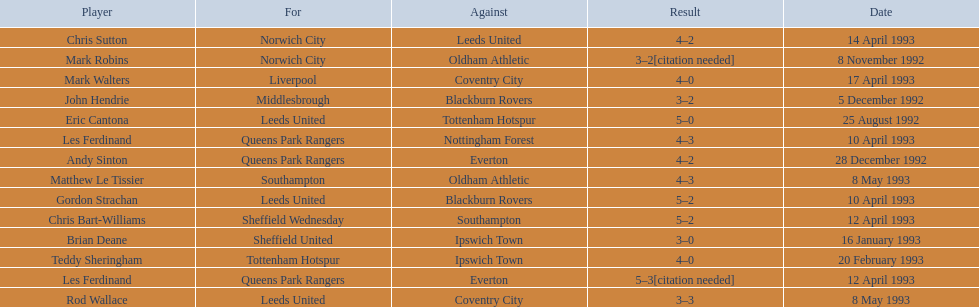What are the results? 5–0, 3–2[citation needed], 3–2, 4–2, 3–0, 4–0, 5–2, 4–3, 5–2, 5–3[citation needed], 4–2, 4–0, 3–3, 4–3. What result did mark robins have? 3–2[citation needed]. What other player had that result? John Hendrie. 